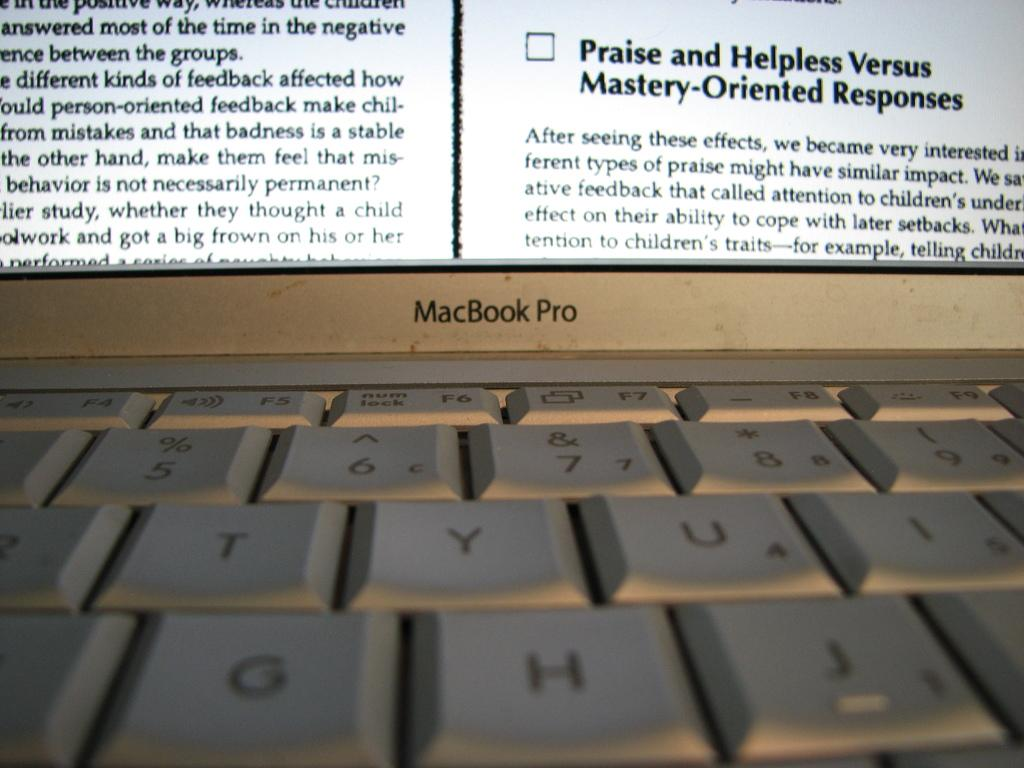What is the main object in the image? There is a laptop screen in the image. What part of the laptop is visible below the screen? The laptop keyboard is visible at the bottom of the screen. What can be seen on the laptop screen? There is text displayed on the laptop screen. What direction is the laptop facing during the war in the image? There is no war or direction mentioned in the image; it only shows a laptop screen with text. 